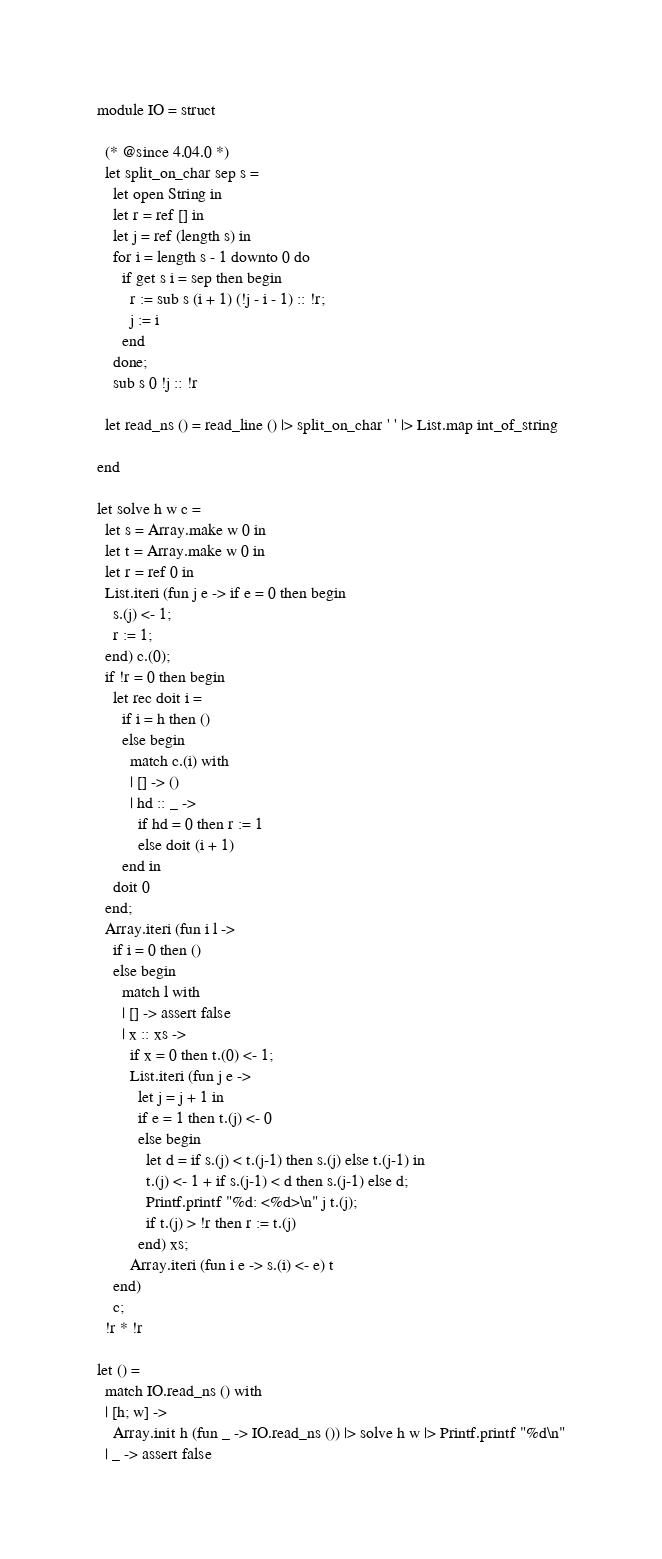Convert code to text. <code><loc_0><loc_0><loc_500><loc_500><_OCaml_>module IO = struct

  (* @since 4.04.0 *)
  let split_on_char sep s =
    let open String in
    let r = ref [] in
    let j = ref (length s) in
    for i = length s - 1 downto 0 do
      if get s i = sep then begin
        r := sub s (i + 1) (!j - i - 1) :: !r;
        j := i
      end
    done;
    sub s 0 !j :: !r

  let read_ns () = read_line () |> split_on_char ' ' |> List.map int_of_string

end

let solve h w c =
  let s = Array.make w 0 in
  let t = Array.make w 0 in
  let r = ref 0 in
  List.iteri (fun j e -> if e = 0 then begin
    s.(j) <- 1;
    r := 1;
  end) c.(0);
  if !r = 0 then begin
    let rec doit i =
      if i = h then ()
      else begin
        match c.(i) with
        | [] -> ()
        | hd :: _ ->
          if hd = 0 then r := 1
          else doit (i + 1)
      end in
    doit 0
  end;
  Array.iteri (fun i l ->
    if i = 0 then ()
    else begin
      match l with
      | [] -> assert false
      | x :: xs ->
        if x = 0 then t.(0) <- 1;
        List.iteri (fun j e ->
          let j = j + 1 in
          if e = 1 then t.(j) <- 0
          else begin
            let d = if s.(j) < t.(j-1) then s.(j) else t.(j-1) in
            t.(j) <- 1 + if s.(j-1) < d then s.(j-1) else d;
            Printf.printf "%d: <%d>\n" j t.(j);
            if t.(j) > !r then r := t.(j)
          end) xs;
        Array.iteri (fun i e -> s.(i) <- e) t
    end)
    c;
  !r * !r

let () =
  match IO.read_ns () with
  | [h; w] ->
    Array.init h (fun _ -> IO.read_ns ()) |> solve h w |> Printf.printf "%d\n"
  | _ -> assert false</code> 